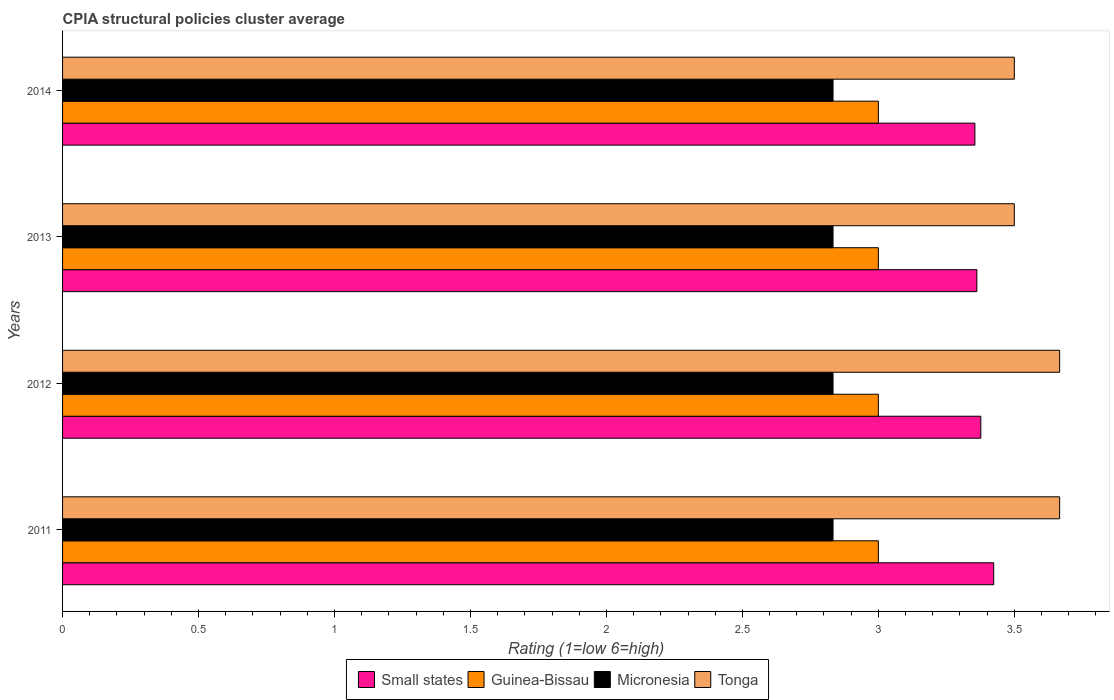Are the number of bars per tick equal to the number of legend labels?
Offer a very short reply. Yes. How many bars are there on the 2nd tick from the bottom?
Make the answer very short. 4. In how many cases, is the number of bars for a given year not equal to the number of legend labels?
Your answer should be compact. 0. What is the CPIA rating in Tonga in 2013?
Give a very brief answer. 3.5. Across all years, what is the maximum CPIA rating in Micronesia?
Your answer should be very brief. 2.83. In which year was the CPIA rating in Micronesia maximum?
Your answer should be very brief. 2011. What is the total CPIA rating in Small states in the graph?
Provide a succinct answer. 13.52. What is the difference between the CPIA rating in Micronesia in 2013 and that in 2014?
Keep it short and to the point. 3.333333329802457e-6. What is the difference between the CPIA rating in Tonga in 2011 and the CPIA rating in Small states in 2012?
Offer a very short reply. 0.29. In the year 2012, what is the difference between the CPIA rating in Small states and CPIA rating in Micronesia?
Offer a very short reply. 0.54. What is the ratio of the CPIA rating in Micronesia in 2012 to that in 2014?
Give a very brief answer. 1. Is the CPIA rating in Tonga in 2012 less than that in 2013?
Provide a short and direct response. No. What is the difference between the highest and the second highest CPIA rating in Guinea-Bissau?
Make the answer very short. 0. What is the difference between the highest and the lowest CPIA rating in Small states?
Offer a terse response. 0.07. Is it the case that in every year, the sum of the CPIA rating in Guinea-Bissau and CPIA rating in Micronesia is greater than the sum of CPIA rating in Tonga and CPIA rating in Small states?
Keep it short and to the point. Yes. What does the 4th bar from the top in 2012 represents?
Provide a short and direct response. Small states. What does the 4th bar from the bottom in 2012 represents?
Keep it short and to the point. Tonga. Is it the case that in every year, the sum of the CPIA rating in Micronesia and CPIA rating in Tonga is greater than the CPIA rating in Small states?
Your answer should be very brief. Yes. How many bars are there?
Your response must be concise. 16. Does the graph contain grids?
Make the answer very short. No. How many legend labels are there?
Your answer should be very brief. 4. How are the legend labels stacked?
Make the answer very short. Horizontal. What is the title of the graph?
Your response must be concise. CPIA structural policies cluster average. Does "Bosnia and Herzegovina" appear as one of the legend labels in the graph?
Provide a short and direct response. No. What is the label or title of the Y-axis?
Give a very brief answer. Years. What is the Rating (1=low 6=high) in Small states in 2011?
Your answer should be very brief. 3.42. What is the Rating (1=low 6=high) in Micronesia in 2011?
Keep it short and to the point. 2.83. What is the Rating (1=low 6=high) in Tonga in 2011?
Make the answer very short. 3.67. What is the Rating (1=low 6=high) in Small states in 2012?
Your answer should be compact. 3.38. What is the Rating (1=low 6=high) in Guinea-Bissau in 2012?
Offer a terse response. 3. What is the Rating (1=low 6=high) in Micronesia in 2012?
Your answer should be compact. 2.83. What is the Rating (1=low 6=high) of Tonga in 2012?
Make the answer very short. 3.67. What is the Rating (1=low 6=high) of Small states in 2013?
Make the answer very short. 3.36. What is the Rating (1=low 6=high) in Guinea-Bissau in 2013?
Give a very brief answer. 3. What is the Rating (1=low 6=high) in Micronesia in 2013?
Offer a terse response. 2.83. What is the Rating (1=low 6=high) in Tonga in 2013?
Provide a succinct answer. 3.5. What is the Rating (1=low 6=high) of Small states in 2014?
Offer a terse response. 3.36. What is the Rating (1=low 6=high) in Guinea-Bissau in 2014?
Make the answer very short. 3. What is the Rating (1=low 6=high) in Micronesia in 2014?
Make the answer very short. 2.83. What is the Rating (1=low 6=high) in Tonga in 2014?
Your response must be concise. 3.5. Across all years, what is the maximum Rating (1=low 6=high) in Small states?
Your answer should be compact. 3.42. Across all years, what is the maximum Rating (1=low 6=high) in Guinea-Bissau?
Your response must be concise. 3. Across all years, what is the maximum Rating (1=low 6=high) of Micronesia?
Your answer should be compact. 2.83. Across all years, what is the maximum Rating (1=low 6=high) of Tonga?
Keep it short and to the point. 3.67. Across all years, what is the minimum Rating (1=low 6=high) of Small states?
Provide a succinct answer. 3.36. Across all years, what is the minimum Rating (1=low 6=high) of Guinea-Bissau?
Offer a very short reply. 3. Across all years, what is the minimum Rating (1=low 6=high) of Micronesia?
Provide a short and direct response. 2.83. What is the total Rating (1=low 6=high) of Small states in the graph?
Your answer should be compact. 13.52. What is the total Rating (1=low 6=high) of Micronesia in the graph?
Keep it short and to the point. 11.33. What is the total Rating (1=low 6=high) in Tonga in the graph?
Offer a very short reply. 14.33. What is the difference between the Rating (1=low 6=high) of Small states in 2011 and that in 2012?
Ensure brevity in your answer.  0.05. What is the difference between the Rating (1=low 6=high) of Guinea-Bissau in 2011 and that in 2012?
Your response must be concise. 0. What is the difference between the Rating (1=low 6=high) of Micronesia in 2011 and that in 2012?
Your answer should be very brief. 0. What is the difference between the Rating (1=low 6=high) of Tonga in 2011 and that in 2012?
Provide a succinct answer. 0. What is the difference between the Rating (1=low 6=high) in Small states in 2011 and that in 2013?
Your answer should be compact. 0.06. What is the difference between the Rating (1=low 6=high) of Guinea-Bissau in 2011 and that in 2013?
Your answer should be compact. 0. What is the difference between the Rating (1=low 6=high) of Tonga in 2011 and that in 2013?
Give a very brief answer. 0.17. What is the difference between the Rating (1=low 6=high) in Small states in 2011 and that in 2014?
Provide a short and direct response. 0.07. What is the difference between the Rating (1=low 6=high) in Small states in 2012 and that in 2013?
Offer a terse response. 0.01. What is the difference between the Rating (1=low 6=high) in Guinea-Bissau in 2012 and that in 2013?
Your response must be concise. 0. What is the difference between the Rating (1=low 6=high) of Micronesia in 2012 and that in 2013?
Your answer should be very brief. 0. What is the difference between the Rating (1=low 6=high) of Small states in 2012 and that in 2014?
Offer a terse response. 0.02. What is the difference between the Rating (1=low 6=high) in Micronesia in 2012 and that in 2014?
Provide a short and direct response. 0. What is the difference between the Rating (1=low 6=high) in Small states in 2013 and that in 2014?
Your answer should be very brief. 0.01. What is the difference between the Rating (1=low 6=high) in Guinea-Bissau in 2013 and that in 2014?
Make the answer very short. 0. What is the difference between the Rating (1=low 6=high) in Tonga in 2013 and that in 2014?
Offer a terse response. 0. What is the difference between the Rating (1=low 6=high) of Small states in 2011 and the Rating (1=low 6=high) of Guinea-Bissau in 2012?
Your response must be concise. 0.42. What is the difference between the Rating (1=low 6=high) of Small states in 2011 and the Rating (1=low 6=high) of Micronesia in 2012?
Provide a short and direct response. 0.59. What is the difference between the Rating (1=low 6=high) in Small states in 2011 and the Rating (1=low 6=high) in Tonga in 2012?
Make the answer very short. -0.24. What is the difference between the Rating (1=low 6=high) of Micronesia in 2011 and the Rating (1=low 6=high) of Tonga in 2012?
Offer a very short reply. -0.83. What is the difference between the Rating (1=low 6=high) in Small states in 2011 and the Rating (1=low 6=high) in Guinea-Bissau in 2013?
Your response must be concise. 0.42. What is the difference between the Rating (1=low 6=high) of Small states in 2011 and the Rating (1=low 6=high) of Micronesia in 2013?
Keep it short and to the point. 0.59. What is the difference between the Rating (1=low 6=high) of Small states in 2011 and the Rating (1=low 6=high) of Tonga in 2013?
Your response must be concise. -0.08. What is the difference between the Rating (1=low 6=high) in Micronesia in 2011 and the Rating (1=low 6=high) in Tonga in 2013?
Keep it short and to the point. -0.67. What is the difference between the Rating (1=low 6=high) of Small states in 2011 and the Rating (1=low 6=high) of Guinea-Bissau in 2014?
Make the answer very short. 0.42. What is the difference between the Rating (1=low 6=high) in Small states in 2011 and the Rating (1=low 6=high) in Micronesia in 2014?
Offer a very short reply. 0.59. What is the difference between the Rating (1=low 6=high) of Small states in 2011 and the Rating (1=low 6=high) of Tonga in 2014?
Provide a short and direct response. -0.08. What is the difference between the Rating (1=low 6=high) in Guinea-Bissau in 2011 and the Rating (1=low 6=high) in Tonga in 2014?
Your answer should be compact. -0.5. What is the difference between the Rating (1=low 6=high) in Micronesia in 2011 and the Rating (1=low 6=high) in Tonga in 2014?
Offer a terse response. -0.67. What is the difference between the Rating (1=low 6=high) of Small states in 2012 and the Rating (1=low 6=high) of Guinea-Bissau in 2013?
Your response must be concise. 0.38. What is the difference between the Rating (1=low 6=high) of Small states in 2012 and the Rating (1=low 6=high) of Micronesia in 2013?
Ensure brevity in your answer.  0.54. What is the difference between the Rating (1=low 6=high) of Small states in 2012 and the Rating (1=low 6=high) of Tonga in 2013?
Ensure brevity in your answer.  -0.12. What is the difference between the Rating (1=low 6=high) of Guinea-Bissau in 2012 and the Rating (1=low 6=high) of Micronesia in 2013?
Keep it short and to the point. 0.17. What is the difference between the Rating (1=low 6=high) of Guinea-Bissau in 2012 and the Rating (1=low 6=high) of Tonga in 2013?
Give a very brief answer. -0.5. What is the difference between the Rating (1=low 6=high) in Small states in 2012 and the Rating (1=low 6=high) in Guinea-Bissau in 2014?
Your answer should be compact. 0.38. What is the difference between the Rating (1=low 6=high) in Small states in 2012 and the Rating (1=low 6=high) in Micronesia in 2014?
Ensure brevity in your answer.  0.54. What is the difference between the Rating (1=low 6=high) in Small states in 2012 and the Rating (1=low 6=high) in Tonga in 2014?
Keep it short and to the point. -0.12. What is the difference between the Rating (1=low 6=high) of Guinea-Bissau in 2012 and the Rating (1=low 6=high) of Tonga in 2014?
Offer a very short reply. -0.5. What is the difference between the Rating (1=low 6=high) of Micronesia in 2012 and the Rating (1=low 6=high) of Tonga in 2014?
Provide a succinct answer. -0.67. What is the difference between the Rating (1=low 6=high) in Small states in 2013 and the Rating (1=low 6=high) in Guinea-Bissau in 2014?
Keep it short and to the point. 0.36. What is the difference between the Rating (1=low 6=high) of Small states in 2013 and the Rating (1=low 6=high) of Micronesia in 2014?
Provide a succinct answer. 0.53. What is the difference between the Rating (1=low 6=high) in Small states in 2013 and the Rating (1=low 6=high) in Tonga in 2014?
Give a very brief answer. -0.14. What is the difference between the Rating (1=low 6=high) of Guinea-Bissau in 2013 and the Rating (1=low 6=high) of Micronesia in 2014?
Provide a succinct answer. 0.17. What is the average Rating (1=low 6=high) in Small states per year?
Keep it short and to the point. 3.38. What is the average Rating (1=low 6=high) of Micronesia per year?
Offer a terse response. 2.83. What is the average Rating (1=low 6=high) in Tonga per year?
Your answer should be compact. 3.58. In the year 2011, what is the difference between the Rating (1=low 6=high) in Small states and Rating (1=low 6=high) in Guinea-Bissau?
Your answer should be compact. 0.42. In the year 2011, what is the difference between the Rating (1=low 6=high) of Small states and Rating (1=low 6=high) of Micronesia?
Your answer should be compact. 0.59. In the year 2011, what is the difference between the Rating (1=low 6=high) in Small states and Rating (1=low 6=high) in Tonga?
Your answer should be very brief. -0.24. In the year 2012, what is the difference between the Rating (1=low 6=high) in Small states and Rating (1=low 6=high) in Guinea-Bissau?
Provide a succinct answer. 0.38. In the year 2012, what is the difference between the Rating (1=low 6=high) of Small states and Rating (1=low 6=high) of Micronesia?
Offer a very short reply. 0.54. In the year 2012, what is the difference between the Rating (1=low 6=high) of Small states and Rating (1=low 6=high) of Tonga?
Your answer should be compact. -0.29. In the year 2012, what is the difference between the Rating (1=low 6=high) of Guinea-Bissau and Rating (1=low 6=high) of Micronesia?
Provide a succinct answer. 0.17. In the year 2012, what is the difference between the Rating (1=low 6=high) of Micronesia and Rating (1=low 6=high) of Tonga?
Your answer should be very brief. -0.83. In the year 2013, what is the difference between the Rating (1=low 6=high) of Small states and Rating (1=low 6=high) of Guinea-Bissau?
Make the answer very short. 0.36. In the year 2013, what is the difference between the Rating (1=low 6=high) in Small states and Rating (1=low 6=high) in Micronesia?
Your response must be concise. 0.53. In the year 2013, what is the difference between the Rating (1=low 6=high) in Small states and Rating (1=low 6=high) in Tonga?
Ensure brevity in your answer.  -0.14. In the year 2013, what is the difference between the Rating (1=low 6=high) in Guinea-Bissau and Rating (1=low 6=high) in Tonga?
Your answer should be very brief. -0.5. In the year 2014, what is the difference between the Rating (1=low 6=high) of Small states and Rating (1=low 6=high) of Guinea-Bissau?
Your answer should be very brief. 0.36. In the year 2014, what is the difference between the Rating (1=low 6=high) in Small states and Rating (1=low 6=high) in Micronesia?
Ensure brevity in your answer.  0.52. In the year 2014, what is the difference between the Rating (1=low 6=high) in Small states and Rating (1=low 6=high) in Tonga?
Ensure brevity in your answer.  -0.14. In the year 2014, what is the difference between the Rating (1=low 6=high) in Guinea-Bissau and Rating (1=low 6=high) in Tonga?
Offer a terse response. -0.5. In the year 2014, what is the difference between the Rating (1=low 6=high) of Micronesia and Rating (1=low 6=high) of Tonga?
Make the answer very short. -0.67. What is the ratio of the Rating (1=low 6=high) of Small states in 2011 to that in 2012?
Give a very brief answer. 1.01. What is the ratio of the Rating (1=low 6=high) in Guinea-Bissau in 2011 to that in 2012?
Your answer should be very brief. 1. What is the ratio of the Rating (1=low 6=high) in Small states in 2011 to that in 2013?
Keep it short and to the point. 1.02. What is the ratio of the Rating (1=low 6=high) in Tonga in 2011 to that in 2013?
Give a very brief answer. 1.05. What is the ratio of the Rating (1=low 6=high) of Small states in 2011 to that in 2014?
Keep it short and to the point. 1.02. What is the ratio of the Rating (1=low 6=high) of Guinea-Bissau in 2011 to that in 2014?
Offer a terse response. 1. What is the ratio of the Rating (1=low 6=high) of Tonga in 2011 to that in 2014?
Provide a succinct answer. 1.05. What is the ratio of the Rating (1=low 6=high) in Tonga in 2012 to that in 2013?
Your answer should be very brief. 1.05. What is the ratio of the Rating (1=low 6=high) of Small states in 2012 to that in 2014?
Offer a terse response. 1.01. What is the ratio of the Rating (1=low 6=high) of Guinea-Bissau in 2012 to that in 2014?
Your response must be concise. 1. What is the ratio of the Rating (1=low 6=high) of Tonga in 2012 to that in 2014?
Give a very brief answer. 1.05. What is the difference between the highest and the second highest Rating (1=low 6=high) of Small states?
Make the answer very short. 0.05. What is the difference between the highest and the second highest Rating (1=low 6=high) of Guinea-Bissau?
Your response must be concise. 0. What is the difference between the highest and the second highest Rating (1=low 6=high) of Micronesia?
Make the answer very short. 0. What is the difference between the highest and the second highest Rating (1=low 6=high) in Tonga?
Your answer should be compact. 0. What is the difference between the highest and the lowest Rating (1=low 6=high) in Small states?
Your answer should be compact. 0.07. What is the difference between the highest and the lowest Rating (1=low 6=high) of Guinea-Bissau?
Ensure brevity in your answer.  0. 